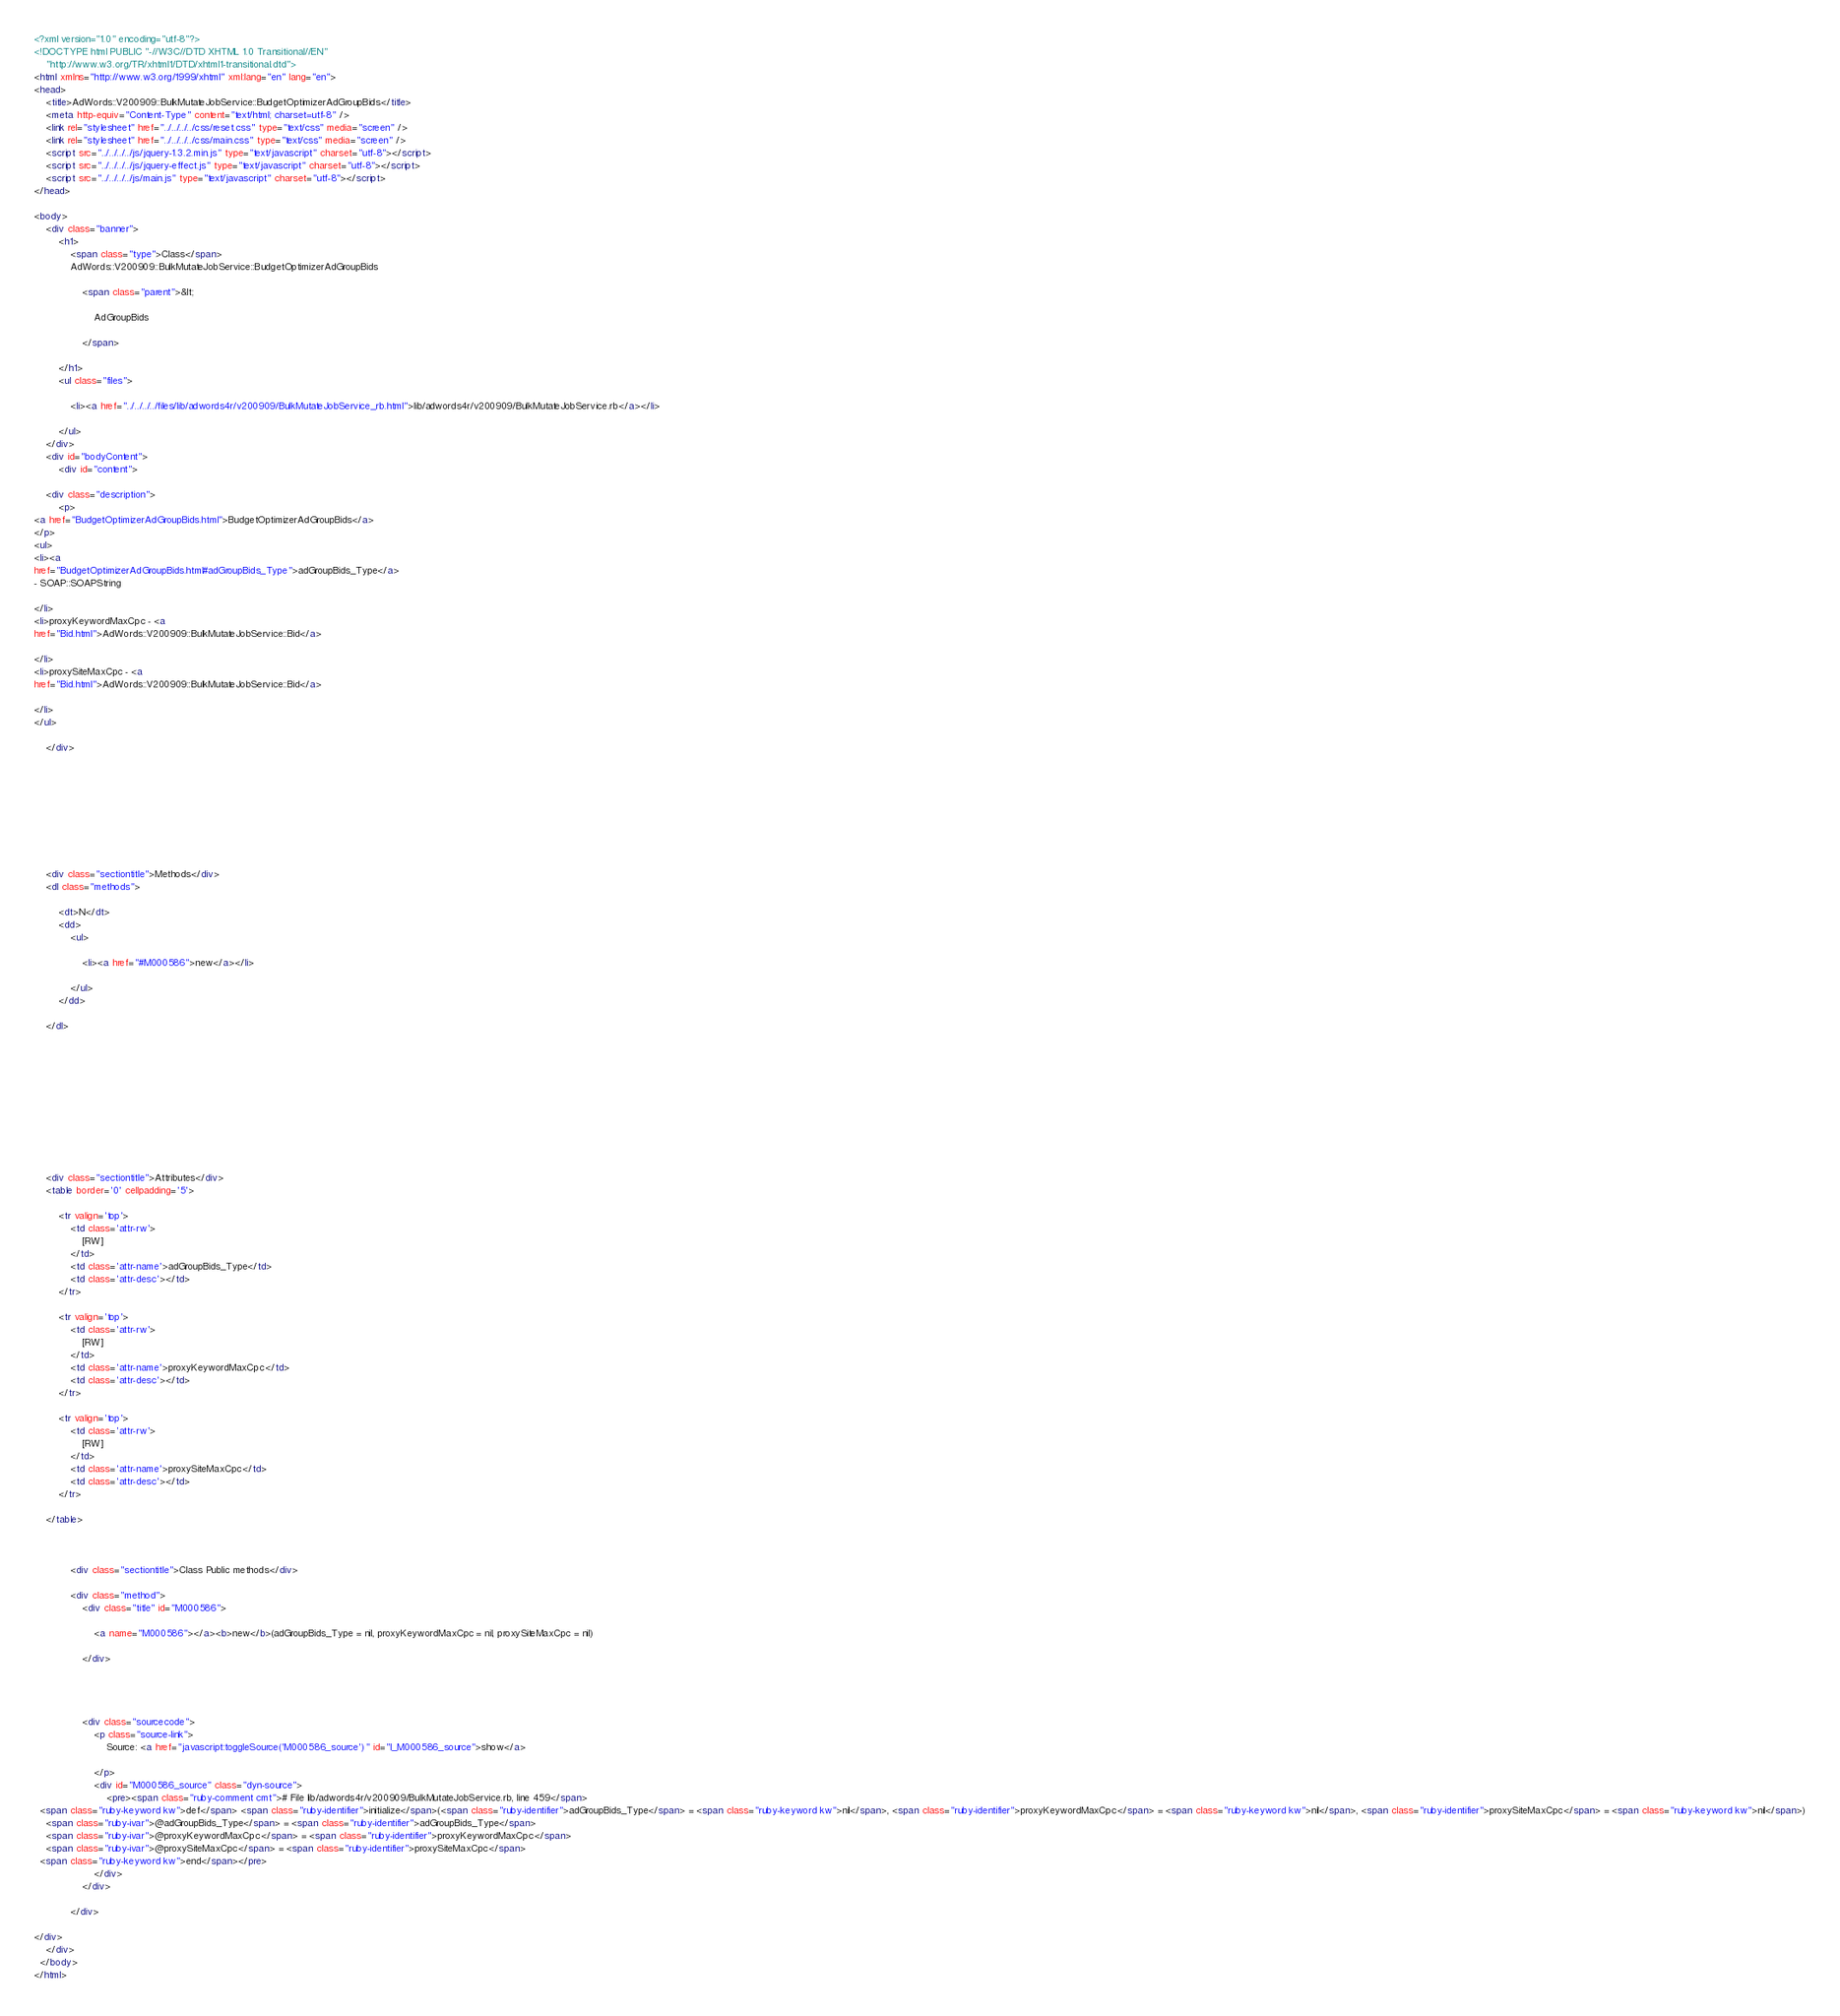<code> <loc_0><loc_0><loc_500><loc_500><_HTML_><?xml version="1.0" encoding="utf-8"?>
<!DOCTYPE html PUBLIC "-//W3C//DTD XHTML 1.0 Transitional//EN"
    "http://www.w3.org/TR/xhtml1/DTD/xhtml1-transitional.dtd">
<html xmlns="http://www.w3.org/1999/xhtml" xml:lang="en" lang="en">
<head>
    <title>AdWords::V200909::BulkMutateJobService::BudgetOptimizerAdGroupBids</title>
    <meta http-equiv="Content-Type" content="text/html; charset=utf-8" />
    <link rel="stylesheet" href="../../../../css/reset.css" type="text/css" media="screen" />
    <link rel="stylesheet" href="../../../../css/main.css" type="text/css" media="screen" />
    <script src="../../../../js/jquery-1.3.2.min.js" type="text/javascript" charset="utf-8"></script>
    <script src="../../../../js/jquery-effect.js" type="text/javascript" charset="utf-8"></script>
    <script src="../../../../js/main.js" type="text/javascript" charset="utf-8"></script>
</head>

<body>     
    <div class="banner">
        <h1>
            <span class="type">Class</span> 
            AdWords::V200909::BulkMutateJobService::BudgetOptimizerAdGroupBids 
            
                <span class="parent">&lt; 
                    
                    AdGroupBids
                    
                </span>
            
        </h1>
        <ul class="files">
            
            <li><a href="../../../../files/lib/adwords4r/v200909/BulkMutateJobService_rb.html">lib/adwords4r/v200909/BulkMutateJobService.rb</a></li>
            
        </ul>
    </div>
    <div id="bodyContent">
        <div id="content">
    
    <div class="description">
        <p>
<a href="BudgetOptimizerAdGroupBids.html">BudgetOptimizerAdGroupBids</a>
</p>
<ul>
<li><a
href="BudgetOptimizerAdGroupBids.html#adGroupBids_Type">adGroupBids_Type</a>
- SOAP::SOAPString

</li>
<li>proxyKeywordMaxCpc - <a
href="Bid.html">AdWords::V200909::BulkMutateJobService::Bid</a>

</li>
<li>proxySiteMaxCpc - <a
href="Bid.html">AdWords::V200909::BulkMutateJobService::Bid</a>

</li>
</ul>

    </div>
    

    

    
    

    
    
    <div class="sectiontitle">Methods</div>
    <dl class="methods">
    
        <dt>N</dt>
        <dd>
            <ul>
                
                <li><a href="#M000586">new</a></li>
                
            </ul>
        </dd>
    
    </dl>
    

    

    

    

    

    
    <div class="sectiontitle">Attributes</div>
    <table border='0' cellpadding='5'>
        
        <tr valign='top'>
            <td class='attr-rw'>
                [RW]
            </td>
            <td class='attr-name'>adGroupBids_Type</td>
            <td class='attr-desc'></td>
        </tr>
        
        <tr valign='top'>
            <td class='attr-rw'>
                [RW]
            </td>
            <td class='attr-name'>proxyKeywordMaxCpc</td>
            <td class='attr-desc'></td>
        </tr>
        
        <tr valign='top'>
            <td class='attr-rw'>
                [RW]
            </td>
            <td class='attr-name'>proxySiteMaxCpc</td>
            <td class='attr-desc'></td>
        </tr>
        
    </table>
    

    
            <div class="sectiontitle">Class Public methods</div>
            
            <div class="method">
                <div class="title" id="M000586">
                    
                    <a name="M000586"></a><b>new</b>(adGroupBids_Type = nil, proxyKeywordMaxCpc = nil, proxySiteMaxCpc = nil)
                    
                </div>
                
                
                
                
                <div class="sourcecode">
                    <p class="source-link">
                        Source: <a href="javascript:toggleSource('M000586_source')" id="l_M000586_source">show</a>
                        
                    </p>
                    <div id="M000586_source" class="dyn-source">
                        <pre><span class="ruby-comment cmt"># File lib/adwords4r/v200909/BulkMutateJobService.rb, line 459</span>
  <span class="ruby-keyword kw">def</span> <span class="ruby-identifier">initialize</span>(<span class="ruby-identifier">adGroupBids_Type</span> = <span class="ruby-keyword kw">nil</span>, <span class="ruby-identifier">proxyKeywordMaxCpc</span> = <span class="ruby-keyword kw">nil</span>, <span class="ruby-identifier">proxySiteMaxCpc</span> = <span class="ruby-keyword kw">nil</span>)
    <span class="ruby-ivar">@adGroupBids_Type</span> = <span class="ruby-identifier">adGroupBids_Type</span>
    <span class="ruby-ivar">@proxyKeywordMaxCpc</span> = <span class="ruby-identifier">proxyKeywordMaxCpc</span>
    <span class="ruby-ivar">@proxySiteMaxCpc</span> = <span class="ruby-identifier">proxySiteMaxCpc</span>
  <span class="ruby-keyword kw">end</span></pre>
                    </div>
                </div>
                
            </div>
            
</div>
    </div>
  </body>
</html>    </code> 